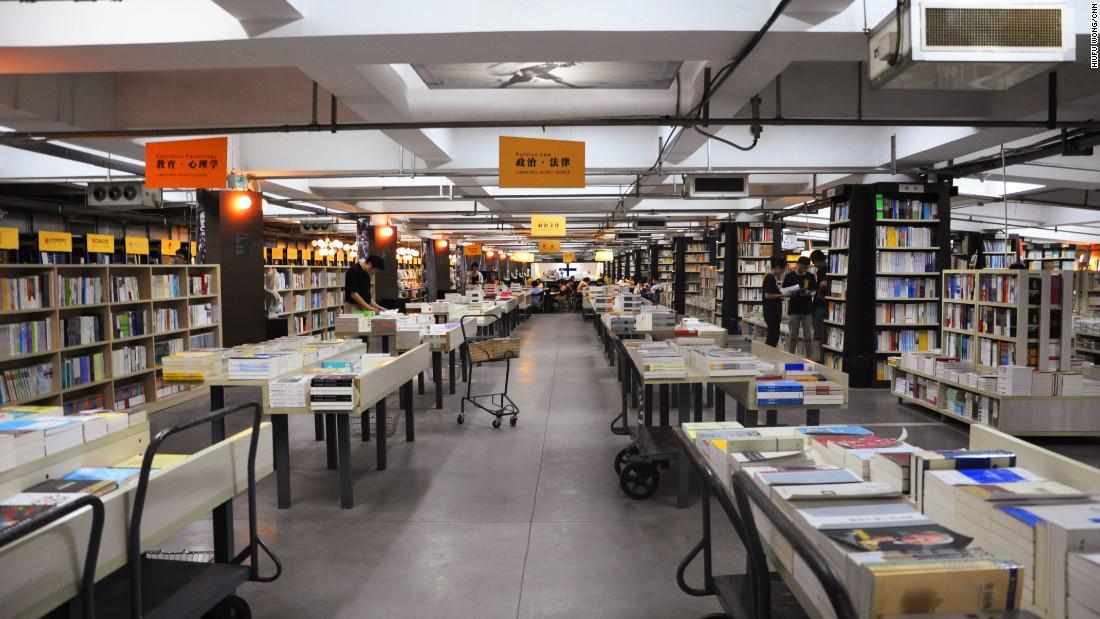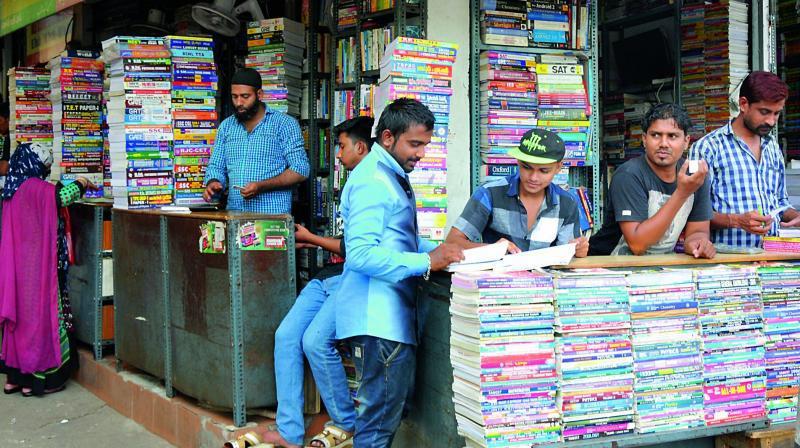The first image is the image on the left, the second image is the image on the right. Analyze the images presented: Is the assertion "At least one image shows a person standing in front of a counter and at least one person in a blue shirt behind a counter, with shelves full of books behind that person." valid? Answer yes or no. Yes. The first image is the image on the left, the second image is the image on the right. Given the left and right images, does the statement "A single person is standing out side the book shop in the image on the left." hold true? Answer yes or no. No. 